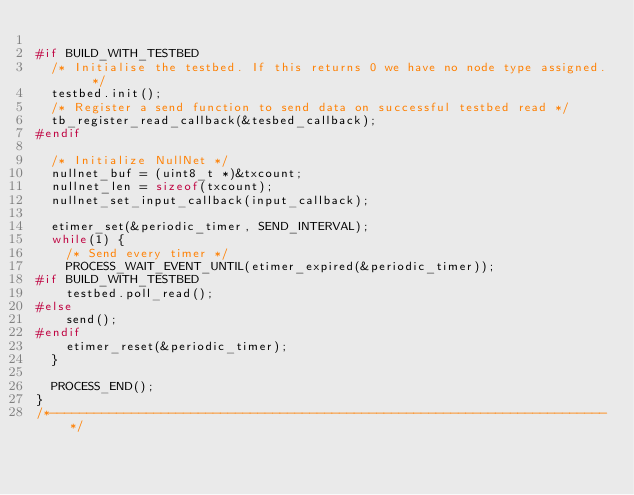<code> <loc_0><loc_0><loc_500><loc_500><_C_>
#if BUILD_WITH_TESTBED
  /* Initialise the testbed. If this returns 0 we have no node type assigned. */
  testbed.init();
  /* Register a send function to send data on successful testbed read */
  tb_register_read_callback(&tesbed_callback);
#endif

  /* Initialize NullNet */
  nullnet_buf = (uint8_t *)&txcount;
  nullnet_len = sizeof(txcount);
  nullnet_set_input_callback(input_callback);

  etimer_set(&periodic_timer, SEND_INTERVAL);
  while(1) {
    /* Send every timer */
    PROCESS_WAIT_EVENT_UNTIL(etimer_expired(&periodic_timer));
#if BUILD_WITH_TESTBED
    testbed.poll_read();
#else
    send();
#endif
    etimer_reset(&periodic_timer);
  }

  PROCESS_END();
}
/*---------------------------------------------------------------------------*/
</code> 